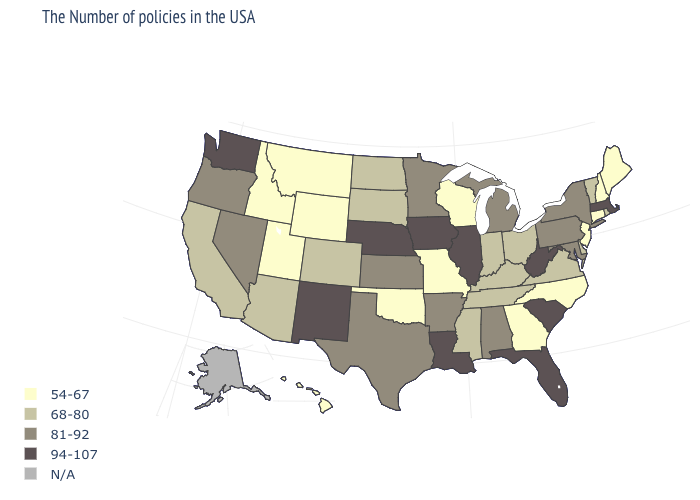Name the states that have a value in the range 68-80?
Be succinct. Rhode Island, Vermont, Delaware, Virginia, Ohio, Kentucky, Indiana, Tennessee, Mississippi, South Dakota, North Dakota, Colorado, Arizona, California. What is the value of Colorado?
Concise answer only. 68-80. Name the states that have a value in the range 54-67?
Be succinct. Maine, New Hampshire, Connecticut, New Jersey, North Carolina, Georgia, Wisconsin, Missouri, Oklahoma, Wyoming, Utah, Montana, Idaho, Hawaii. What is the value of Nevada?
Concise answer only. 81-92. Name the states that have a value in the range 68-80?
Give a very brief answer. Rhode Island, Vermont, Delaware, Virginia, Ohio, Kentucky, Indiana, Tennessee, Mississippi, South Dakota, North Dakota, Colorado, Arizona, California. Does the map have missing data?
Answer briefly. Yes. What is the highest value in the South ?
Be succinct. 94-107. Which states hav the highest value in the Northeast?
Answer briefly. Massachusetts. Does the first symbol in the legend represent the smallest category?
Short answer required. Yes. Which states hav the highest value in the MidWest?
Write a very short answer. Illinois, Iowa, Nebraska. Is the legend a continuous bar?
Answer briefly. No. What is the lowest value in states that border Colorado?
Answer briefly. 54-67. What is the highest value in states that border Texas?
Give a very brief answer. 94-107. Name the states that have a value in the range 54-67?
Be succinct. Maine, New Hampshire, Connecticut, New Jersey, North Carolina, Georgia, Wisconsin, Missouri, Oklahoma, Wyoming, Utah, Montana, Idaho, Hawaii. What is the lowest value in states that border Kansas?
Short answer required. 54-67. 